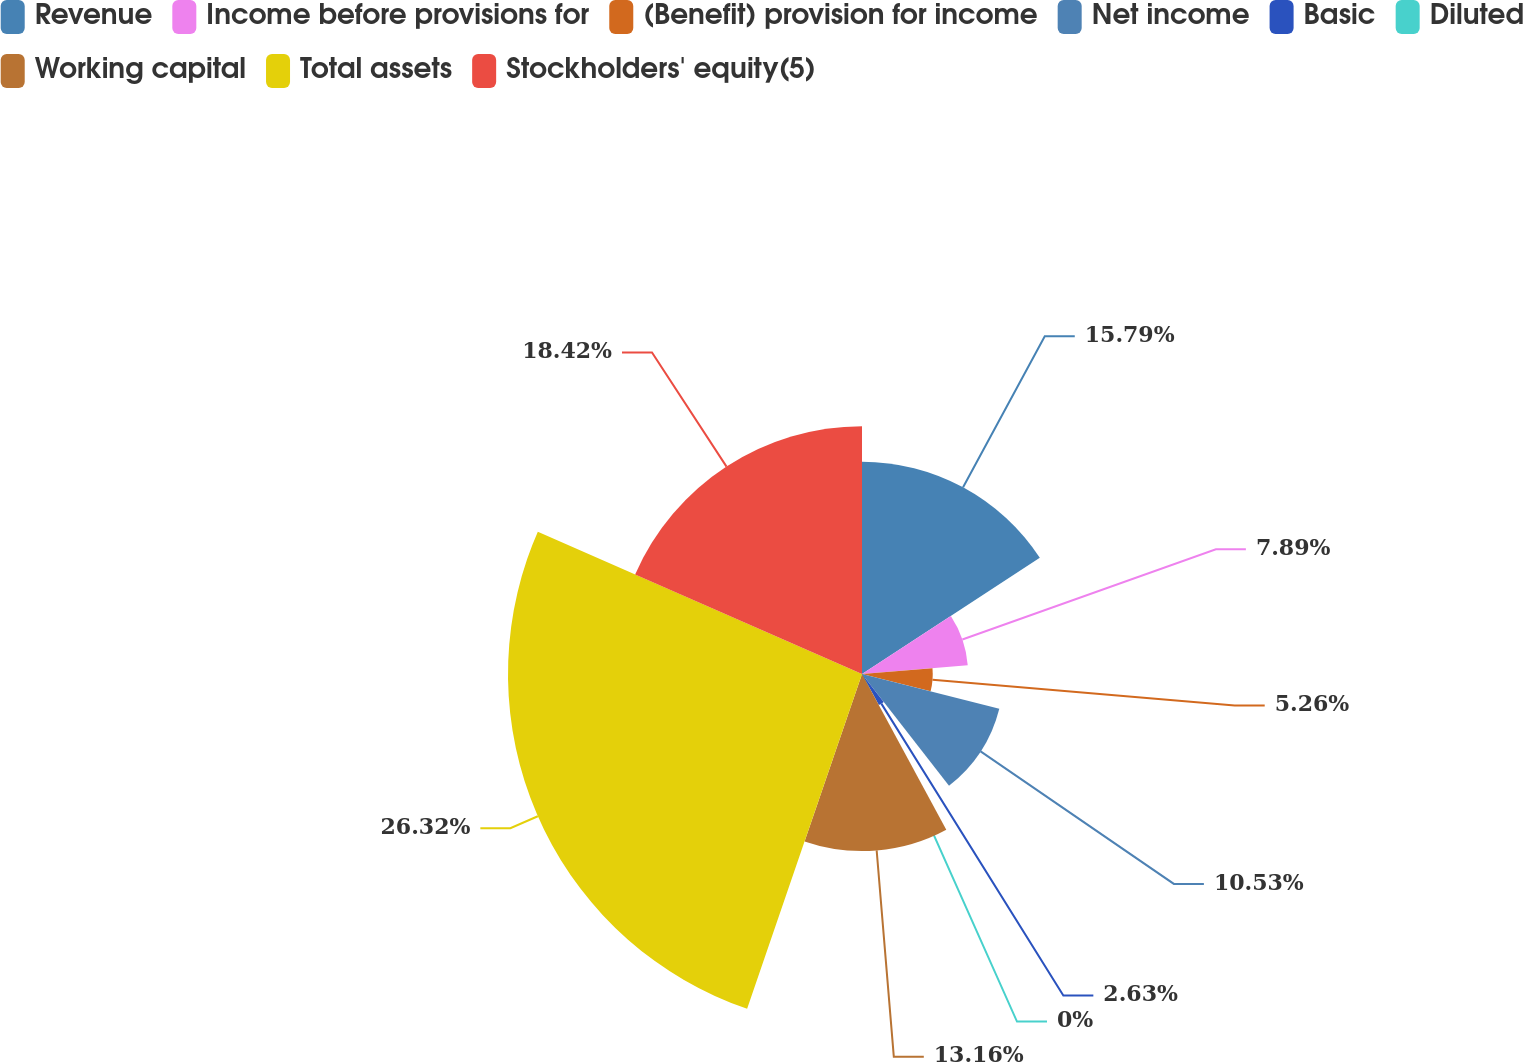Convert chart. <chart><loc_0><loc_0><loc_500><loc_500><pie_chart><fcel>Revenue<fcel>Income before provisions for<fcel>(Benefit) provision for income<fcel>Net income<fcel>Basic<fcel>Diluted<fcel>Working capital<fcel>Total assets<fcel>Stockholders' equity(5)<nl><fcel>15.79%<fcel>7.89%<fcel>5.26%<fcel>10.53%<fcel>2.63%<fcel>0.0%<fcel>13.16%<fcel>26.32%<fcel>18.42%<nl></chart> 